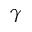<formula> <loc_0><loc_0><loc_500><loc_500>\gamma</formula> 